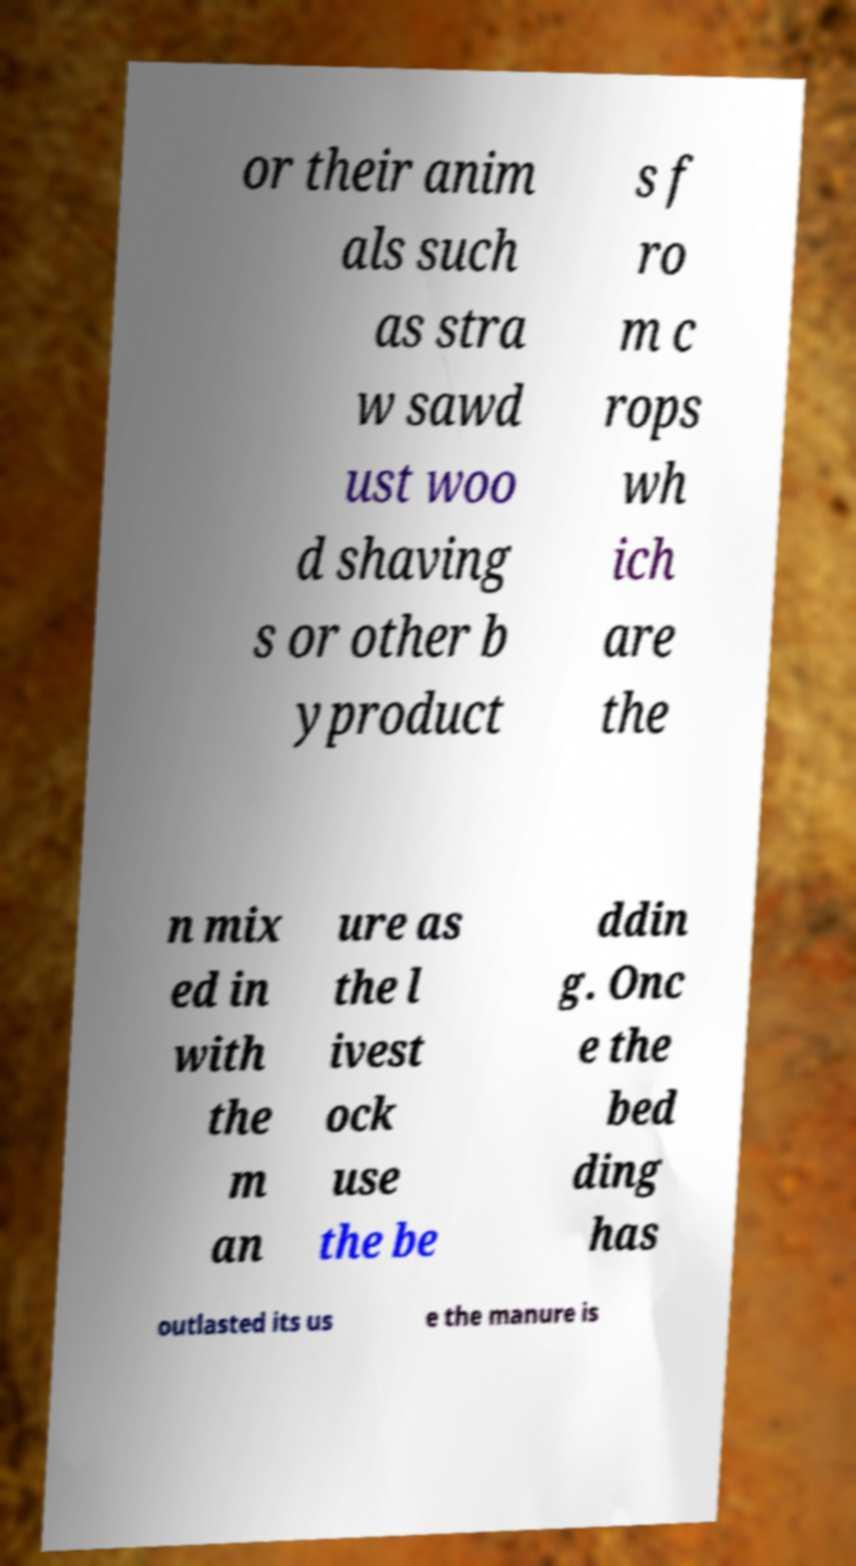Please read and relay the text visible in this image. What does it say? or their anim als such as stra w sawd ust woo d shaving s or other b yproduct s f ro m c rops wh ich are the n mix ed in with the m an ure as the l ivest ock use the be ddin g. Onc e the bed ding has outlasted its us e the manure is 